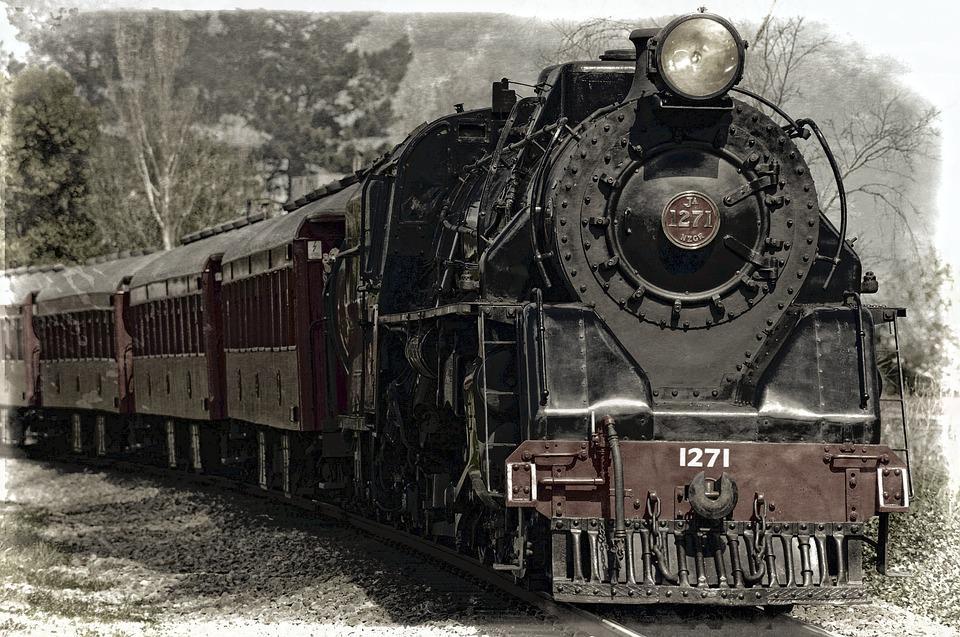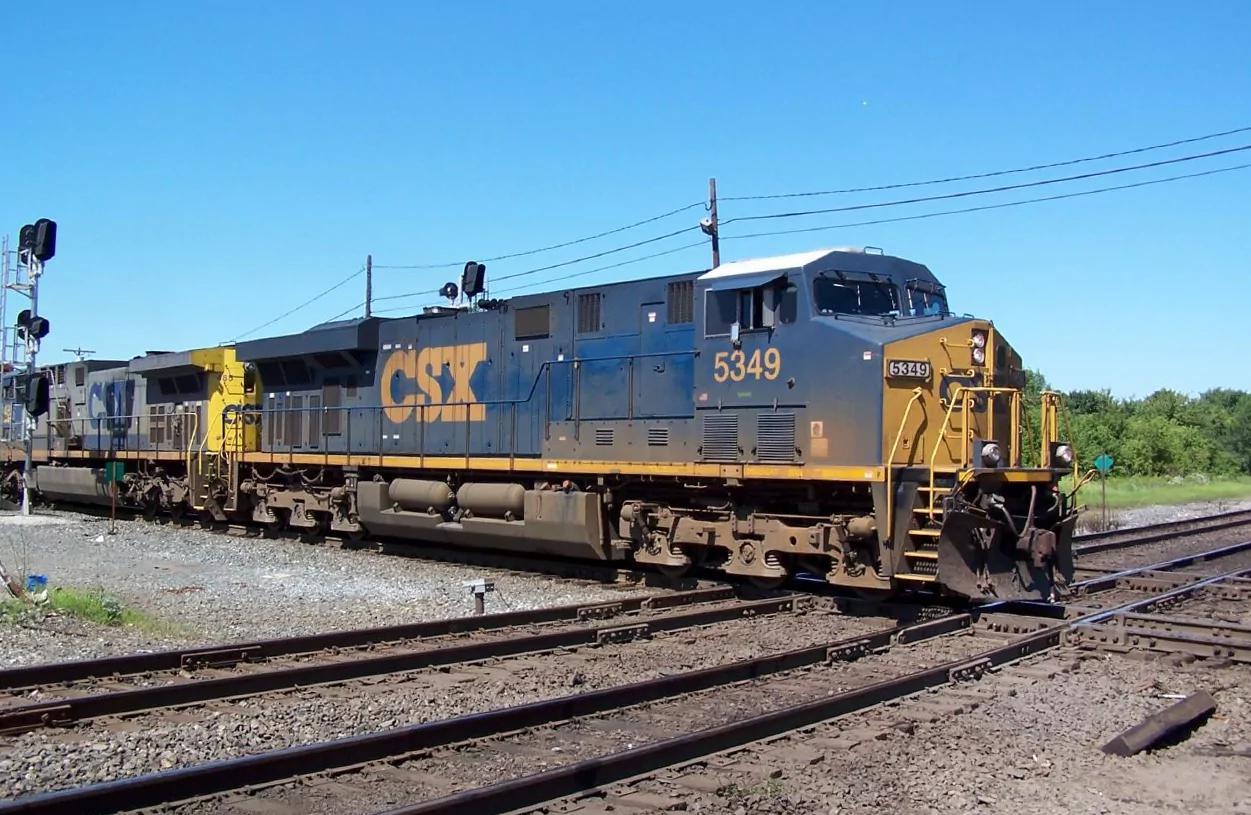The first image is the image on the left, the second image is the image on the right. Examine the images to the left and right. Is the description "The train in the left image is heading towards the left." accurate? Answer yes or no. No. The first image is the image on the left, the second image is the image on the right. For the images displayed, is the sentence "There are two trains moving towards the right." factually correct? Answer yes or no. Yes. 